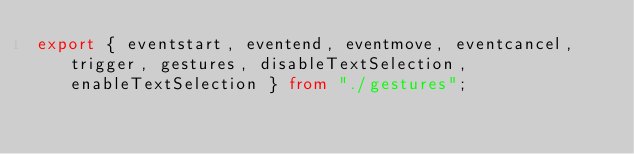Convert code to text. <code><loc_0><loc_0><loc_500><loc_500><_TypeScript_>export { eventstart, eventend, eventmove, eventcancel, trigger, gestures, disableTextSelection, enableTextSelection } from "./gestures";
</code> 